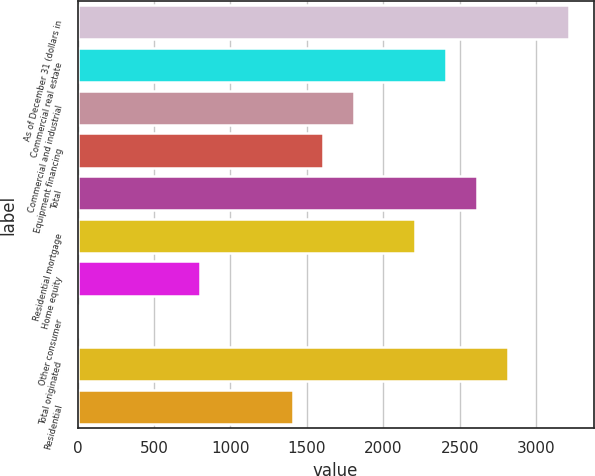<chart> <loc_0><loc_0><loc_500><loc_500><bar_chart><fcel>As of December 31 (dollars in<fcel>Commercial real estate<fcel>Commercial and industrial<fcel>Equipment financing<fcel>Total<fcel>Residential mortgage<fcel>Home equity<fcel>Other consumer<fcel>Total originated<fcel>Residential<nl><fcel>3215.64<fcel>2411.88<fcel>1809.06<fcel>1608.12<fcel>2612.82<fcel>2210.94<fcel>804.36<fcel>0.6<fcel>2813.76<fcel>1407.18<nl></chart> 